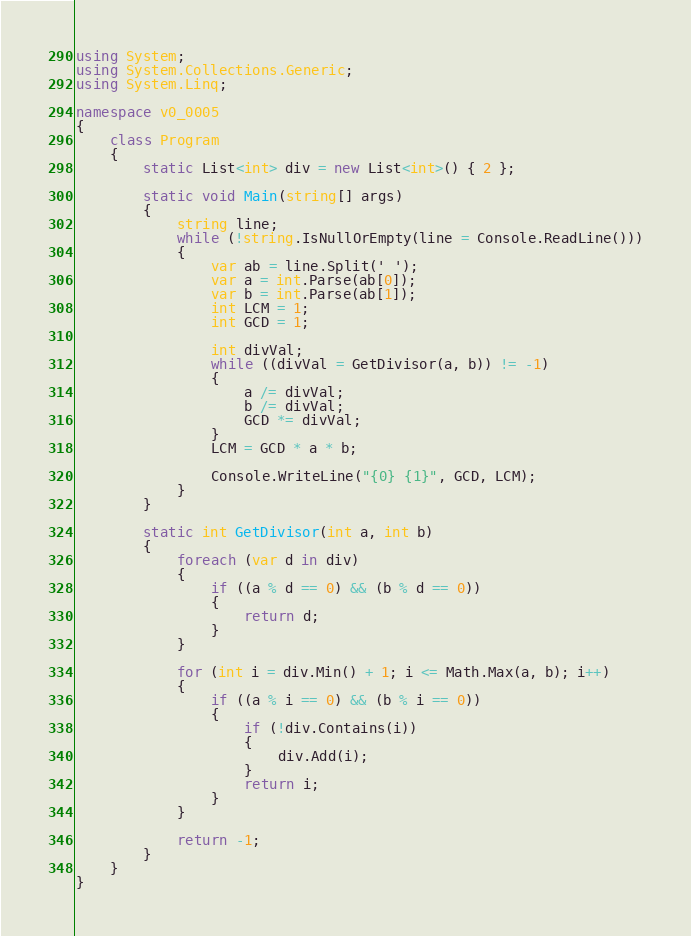<code> <loc_0><loc_0><loc_500><loc_500><_C#_>using System;
using System.Collections.Generic;
using System.Linq;

namespace v0_0005
{
    class Program
    {
        static List<int> div = new List<int>() { 2 };

        static void Main(string[] args)
        {
            string line;
            while (!string.IsNullOrEmpty(line = Console.ReadLine()))
            {
                var ab = line.Split(' ');
                var a = int.Parse(ab[0]);
                var b = int.Parse(ab[1]);
                int LCM = 1;
                int GCD = 1;

                int divVal;
                while ((divVal = GetDivisor(a, b)) != -1)
                {
                    a /= divVal;
                    b /= divVal;
                    GCD *= divVal;
                }
                LCM = GCD * a * b;

                Console.WriteLine("{0} {1}", GCD, LCM);
            }
        }

        static int GetDivisor(int a, int b)
        {
            foreach (var d in div)
            {
                if ((a % d == 0) && (b % d == 0))
                {
                    return d;
                }
            }

            for (int i = div.Min() + 1; i <= Math.Max(a, b); i++)
            {
                if ((a % i == 0) && (b % i == 0))
                {
                    if (!div.Contains(i))
                    {
                        div.Add(i);
                    }
                    return i;
                }
            }

            return -1;
        }
    }
}</code> 